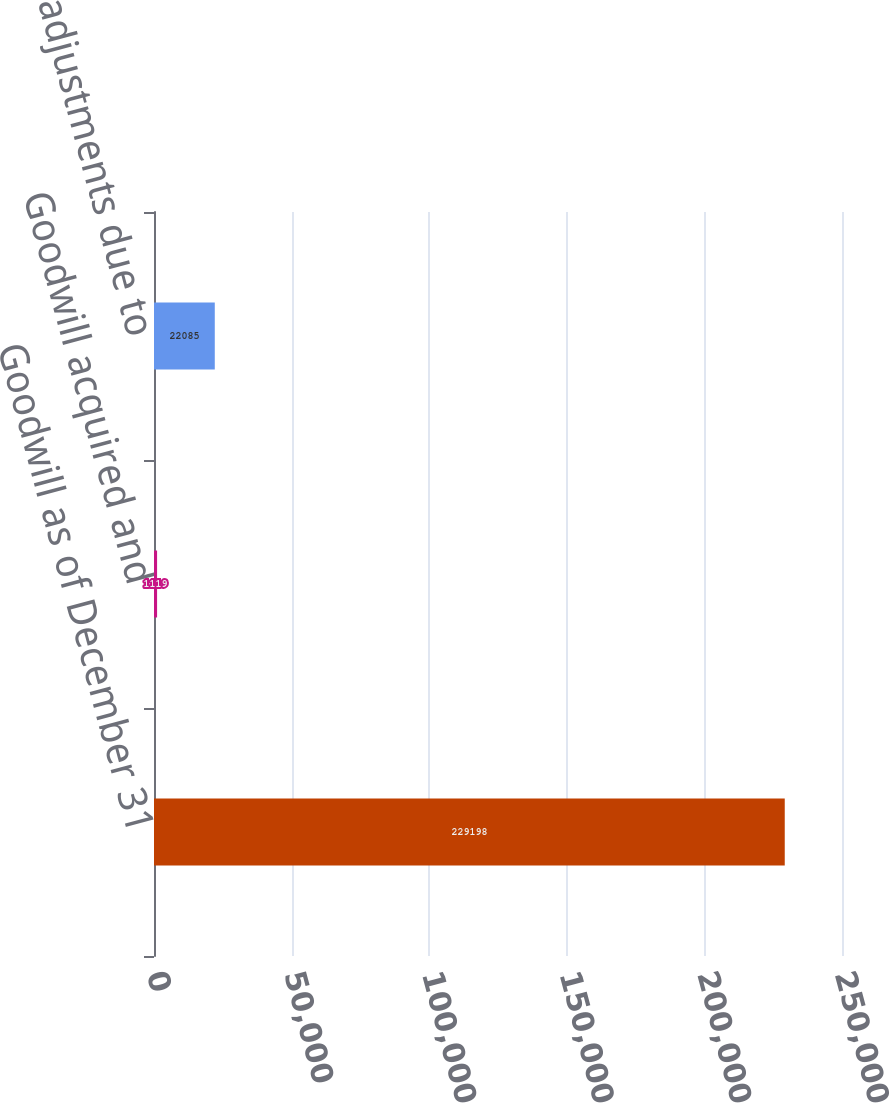Convert chart. <chart><loc_0><loc_0><loc_500><loc_500><bar_chart><fcel>Goodwill as of December 31<fcel>Goodwill acquired and<fcel>Goodwill adjustments due to<nl><fcel>229198<fcel>1119<fcel>22085<nl></chart> 